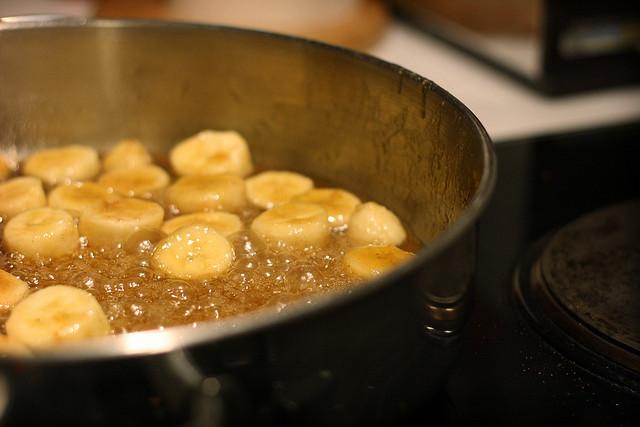What type of stove is this?
Be succinct. Electric. Are those bananas?
Be succinct. Yes. What is in the pot?
Quick response, please. Bananas. What is the orange food in the pot?
Be succinct. Bananas. What is frying in the pan?
Answer briefly. Bananas. 